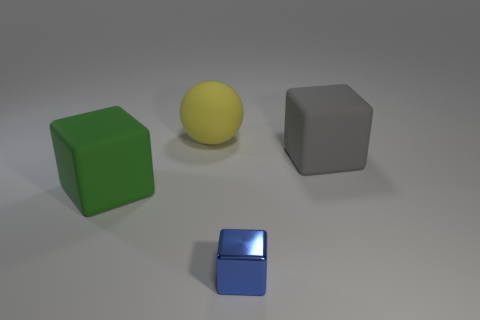Are there any other green blocks made of the same material as the large green block? no 